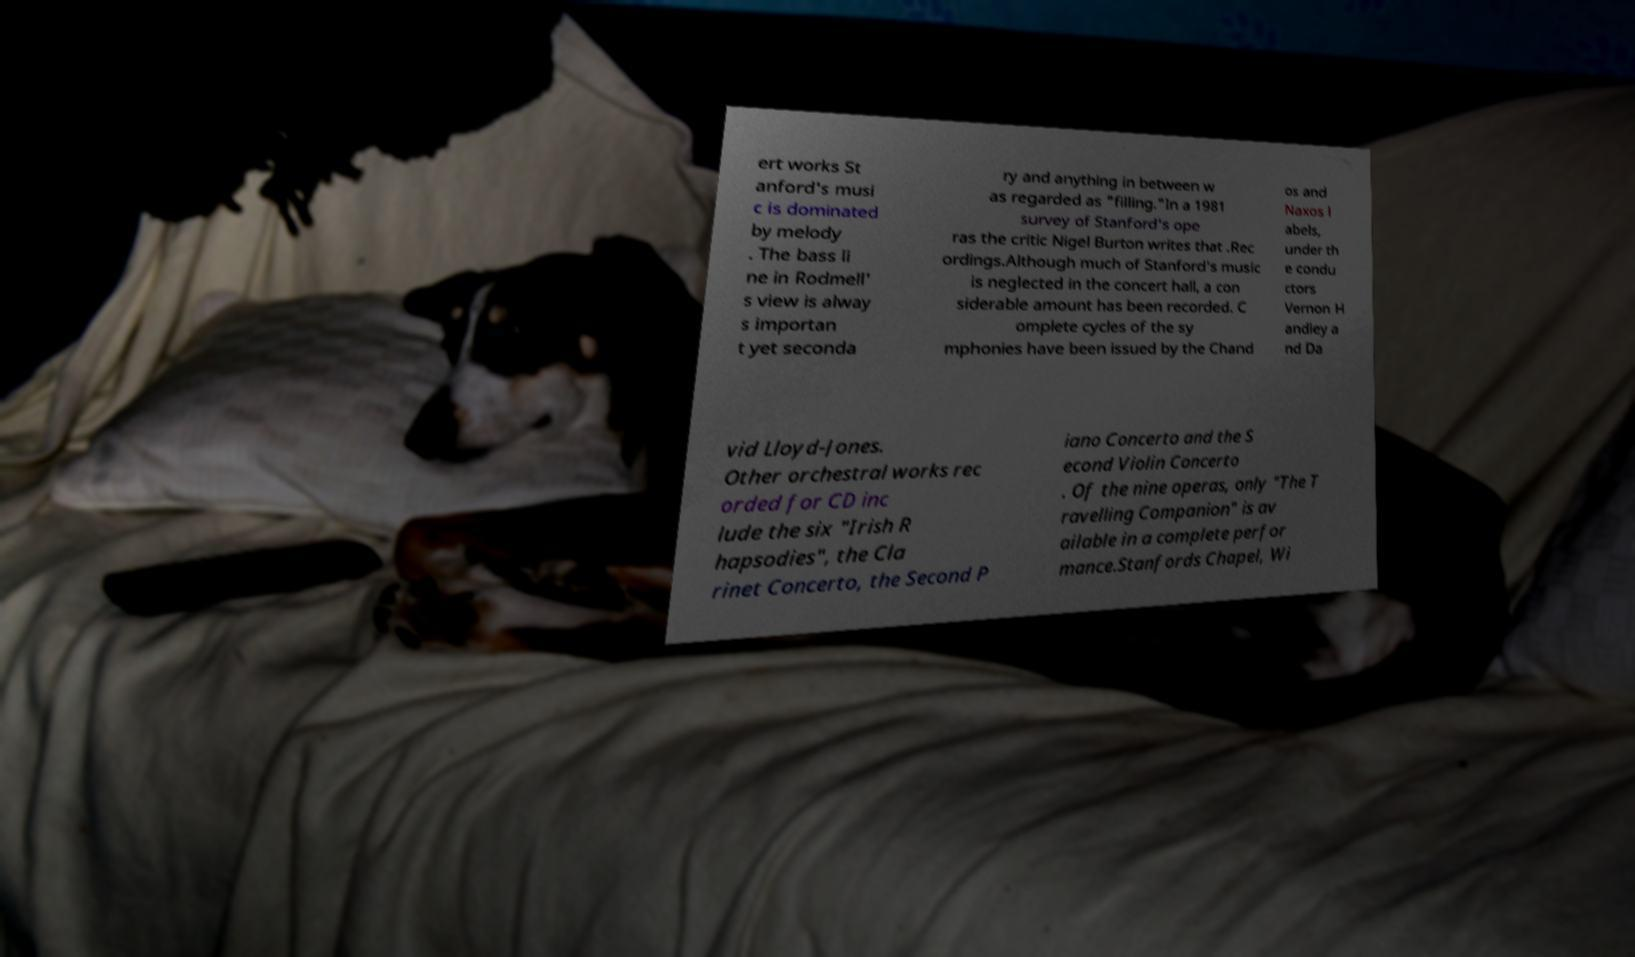Could you assist in decoding the text presented in this image and type it out clearly? ert works St anford's musi c is dominated by melody . The bass li ne in Rodmell' s view is alway s importan t yet seconda ry and anything in between w as regarded as "filling."In a 1981 survey of Stanford's ope ras the critic Nigel Burton writes that .Rec ordings.Although much of Stanford's music is neglected in the concert hall, a con siderable amount has been recorded. C omplete cycles of the sy mphonies have been issued by the Chand os and Naxos l abels, under th e condu ctors Vernon H andley a nd Da vid Lloyd-Jones. Other orchestral works rec orded for CD inc lude the six "Irish R hapsodies", the Cla rinet Concerto, the Second P iano Concerto and the S econd Violin Concerto . Of the nine operas, only "The T ravelling Companion" is av ailable in a complete perfor mance.Stanfords Chapel, Wi 